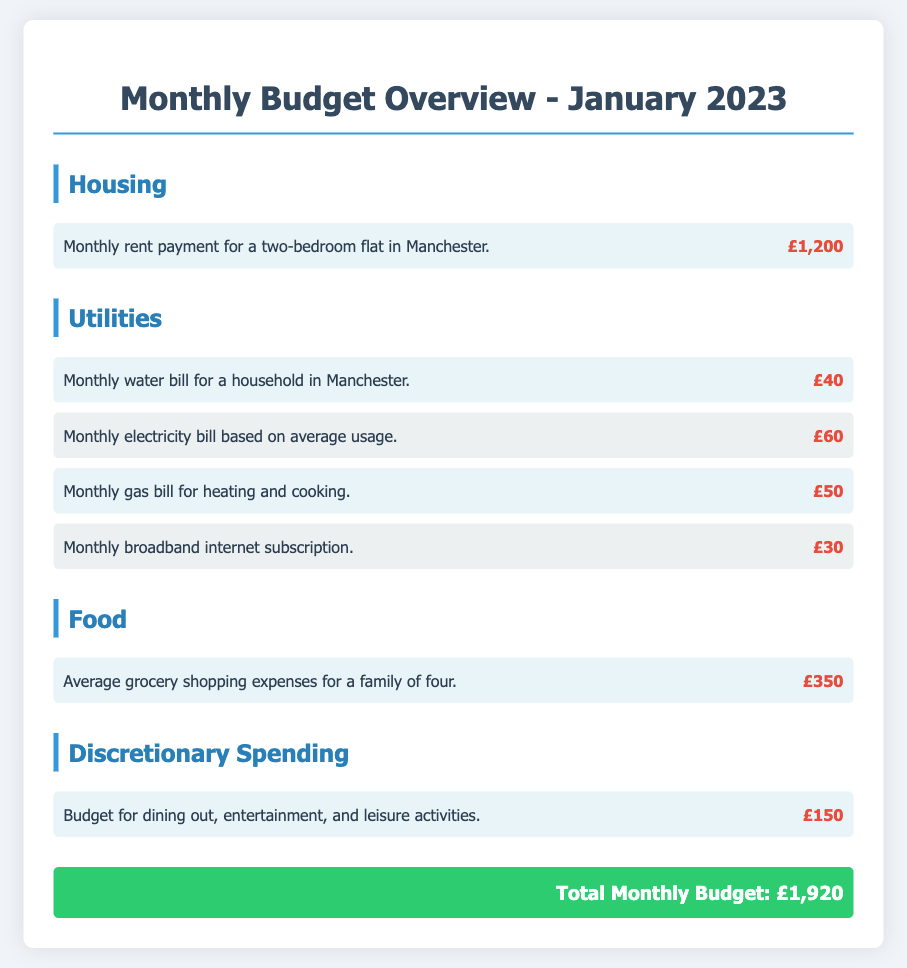What is the monthly rent payment? The monthly rent payment is listed under the housing section as £1,200.
Answer: £1,200 What is the total monthly budget? The total monthly budget is provided at the end of the document, summing all expenses to £1,920.
Answer: £1,920 How much is the monthly electricity bill? The monthly electricity bill is specified in the utilities section as £60.
Answer: £60 What are the average grocery shopping expenses? The average grocery shopping expenses for a family of four are detailed in the food section as £350.
Answer: £350 What is the budget for discretionary spending? The budget for discretionary spending is mentioned in the discretionary spending section as £150.
Answer: £150 How many utility bills are listed in the document? There are four utility bills detailed in the utilities section - water, electricity, gas, and broadband.
Answer: Four What is the total amount spent on utilities? The total amount spent on utilities can be calculated by adding all utility costs: £40 + £60 + £50 + £30 = £180.
Answer: £180 Which section contains the expenses for leisure activities? The discretionary spending section includes the budget for leisure activities.
Answer: Discretionary Spending What is the cost of the monthly gas bill? The monthly gas bill is stated as £50.
Answer: £50 